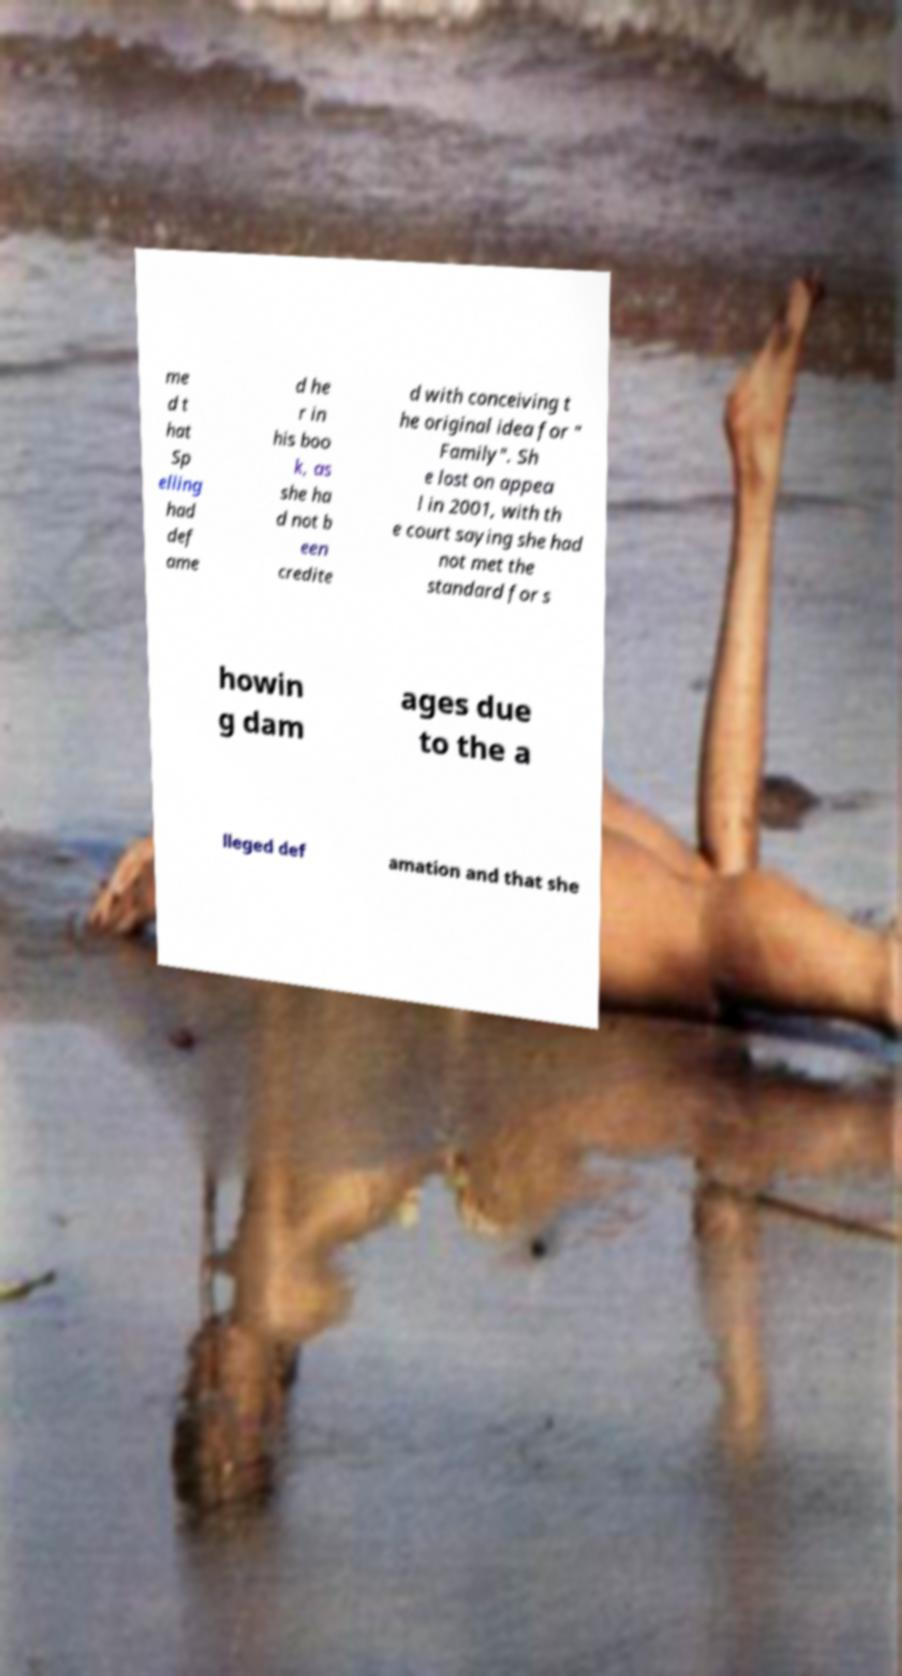There's text embedded in this image that I need extracted. Can you transcribe it verbatim? me d t hat Sp elling had def ame d he r in his boo k, as she ha d not b een credite d with conceiving t he original idea for " Family". Sh e lost on appea l in 2001, with th e court saying she had not met the standard for s howin g dam ages due to the a lleged def amation and that she 